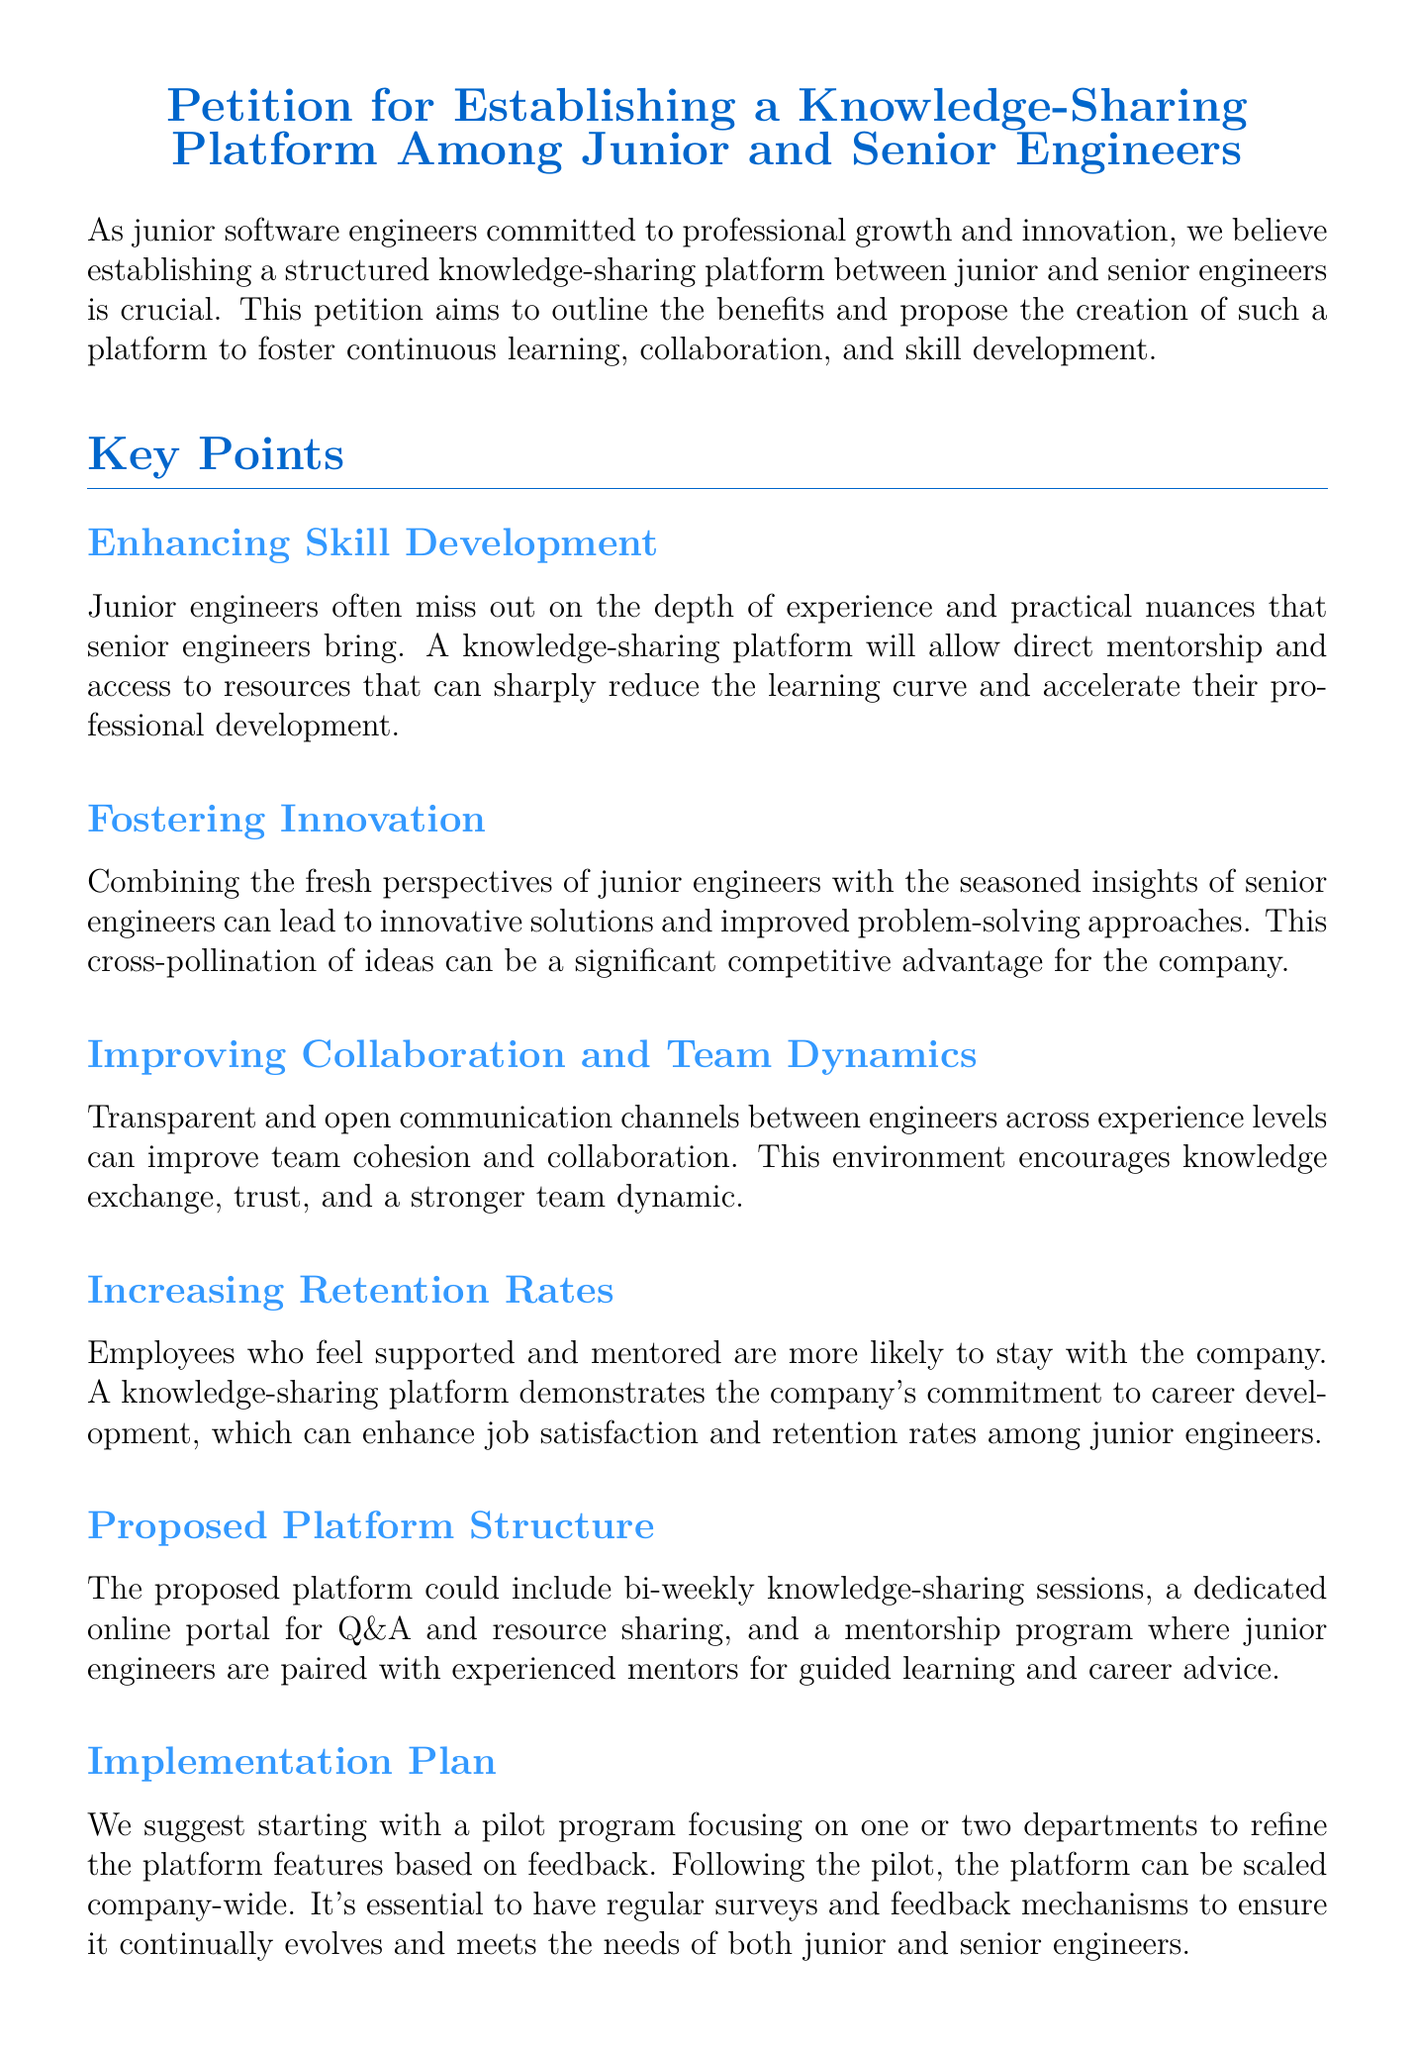What is the main purpose of the petition? The main purpose of the petition is to outline the benefits and propose the creation of a structured knowledge-sharing platform between junior and senior engineers.
Answer: Knowledge-sharing platform How often are the proposed knowledge-sharing sessions? The proposed knowledge-sharing sessions are suggested to be bi-weekly.
Answer: Bi-weekly What is one key point mentioned for enhancing skill development? One key point mentioned is that junior engineers often miss out on the depth of experience and practical nuances that senior engineers bring.
Answer: Depth of experience What is the expected outcome of fostering innovation according to the document? The expected outcome is to lead to innovative solutions and improved problem-solving approaches.
Answer: Innovative solutions Who is urged in the conclusion to consider this proposal? The conclusion urges the leadership to consider this proposal.
Answer: Leadership What is one suggested feature of the proposed platform? One suggested feature of the proposed platform is a dedicated online portal for Q&A and resource sharing.
Answer: Online portal What does the petition emphasize about employee retention? The petition emphasizes that employees who feel supported and mentored are more likely to stay with the company.
Answer: Supported and mentored What is the initial implementation plan for the proposed platform? The initial implementation plan suggests starting with a pilot program focusing on one or two departments.
Answer: Pilot program 